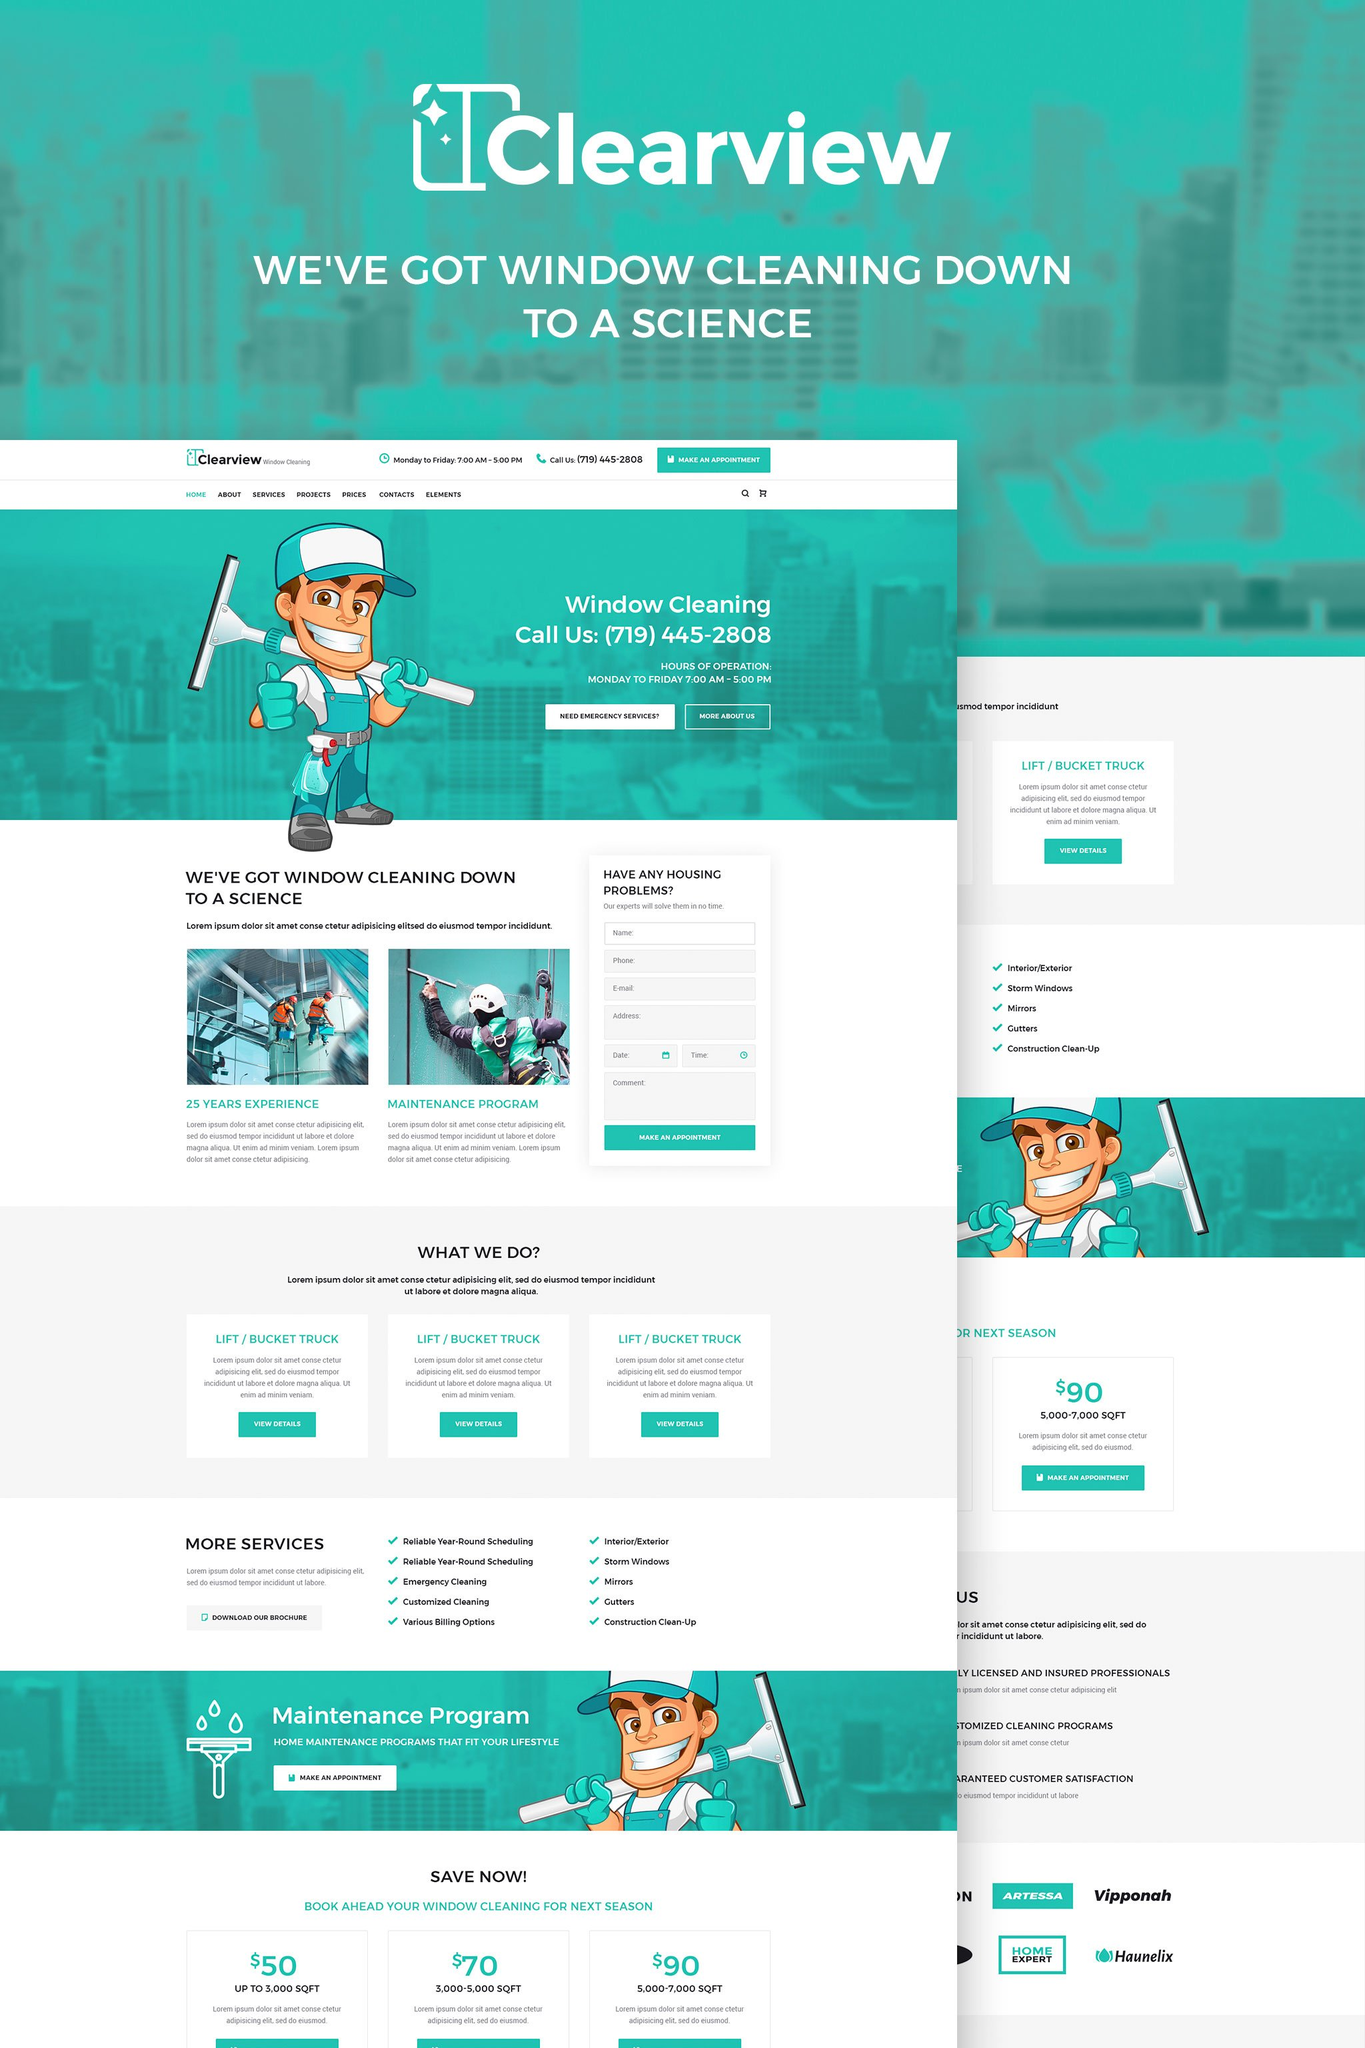What might be the primary value proposition of Clearview's window cleaning service as presented on this webpage, and how is it conveyed through the design and content elements? Clearview’s window cleaning service prominently presents its value proposition through a blend of experienced professionalism and customer-focused features. The assertion of '25 years experience' directly communicates durability and expertise, critically supported by the licensing and insurance badges which enhance their credence as trust-worthy service providers. The tagline 'WE'VE GOT WINDOW CLEANING DOWN TO A SCIENCE' not only reinforces their methodical approach towards window cleaning but also serves as a catchy, memorable phrase that effectively seals their professional identity. Visually, the webpage is structured with a clean, modern design using soothing turquoise tones synonymous with clarity and cleanliness. The cartoon mascot adds a friendly, approachable face to the service, making it more relatable to diverse clientele. Each section of the site uses bold and clear typography to ensure that the information is easily accessible, further complemented by high-quality images that illustrate the effectiveness of their services. Additionally, they offer a maintenance program and promotional offers, emphasizing their commitment to ongoing customer relationships and value. 